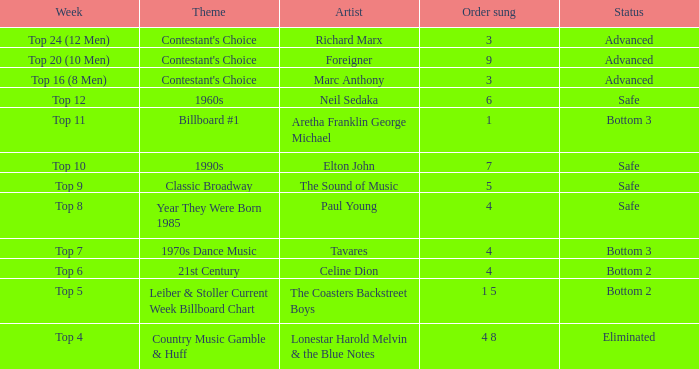What was the theme for the Top 11 week? Billboard #1. 